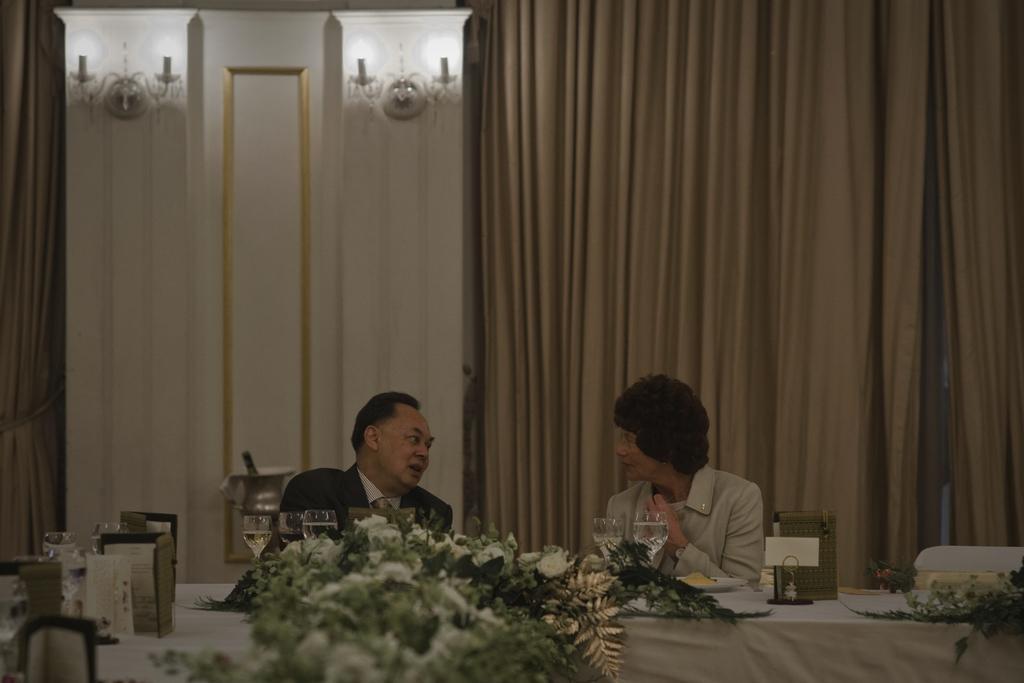Describe this image in one or two sentences. A man and a woman are talking to each other sitting at a table. 